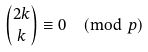Convert formula to latex. <formula><loc_0><loc_0><loc_500><loc_500>\binom { 2 k } k \equiv 0 \pmod { p }</formula> 